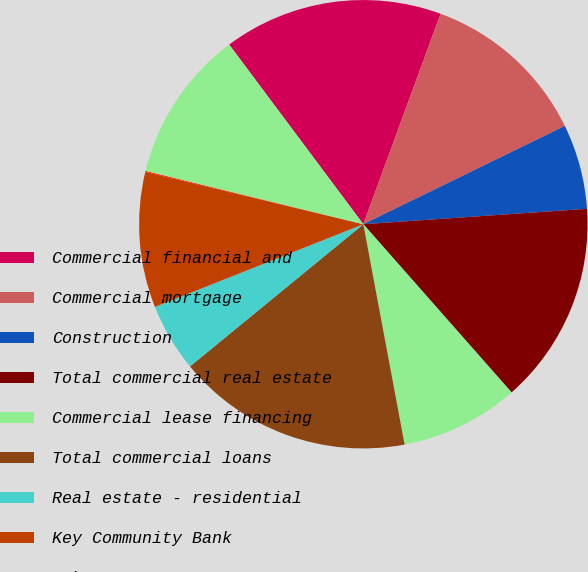<chart> <loc_0><loc_0><loc_500><loc_500><pie_chart><fcel>Commercial financial and<fcel>Commercial mortgage<fcel>Construction<fcel>Total commercial real estate<fcel>Commercial lease financing<fcel>Total commercial loans<fcel>Real estate - residential<fcel>Key Community Bank<fcel>Other<fcel>Total home equity loans<nl><fcel>15.81%<fcel>12.18%<fcel>6.13%<fcel>14.6%<fcel>8.55%<fcel>17.02%<fcel>4.92%<fcel>9.76%<fcel>0.08%<fcel>10.97%<nl></chart> 